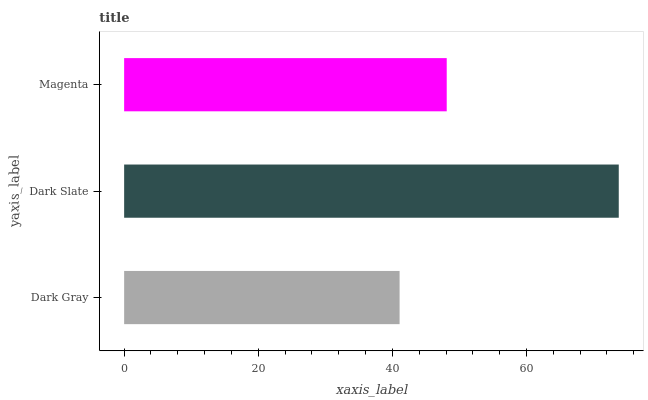Is Dark Gray the minimum?
Answer yes or no. Yes. Is Dark Slate the maximum?
Answer yes or no. Yes. Is Magenta the minimum?
Answer yes or no. No. Is Magenta the maximum?
Answer yes or no. No. Is Dark Slate greater than Magenta?
Answer yes or no. Yes. Is Magenta less than Dark Slate?
Answer yes or no. Yes. Is Magenta greater than Dark Slate?
Answer yes or no. No. Is Dark Slate less than Magenta?
Answer yes or no. No. Is Magenta the high median?
Answer yes or no. Yes. Is Magenta the low median?
Answer yes or no. Yes. Is Dark Slate the high median?
Answer yes or no. No. Is Dark Gray the low median?
Answer yes or no. No. 